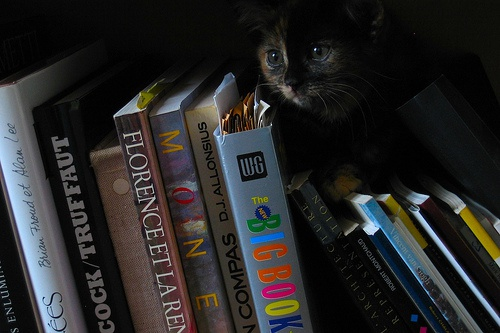Describe the objects in this image and their specific colors. I can see cat in black and gray tones, book in black and gray tones, book in black, gray, and blue tones, book in black, gray, lightblue, and darkgray tones, and book in black, maroon, gray, and darkgray tones in this image. 